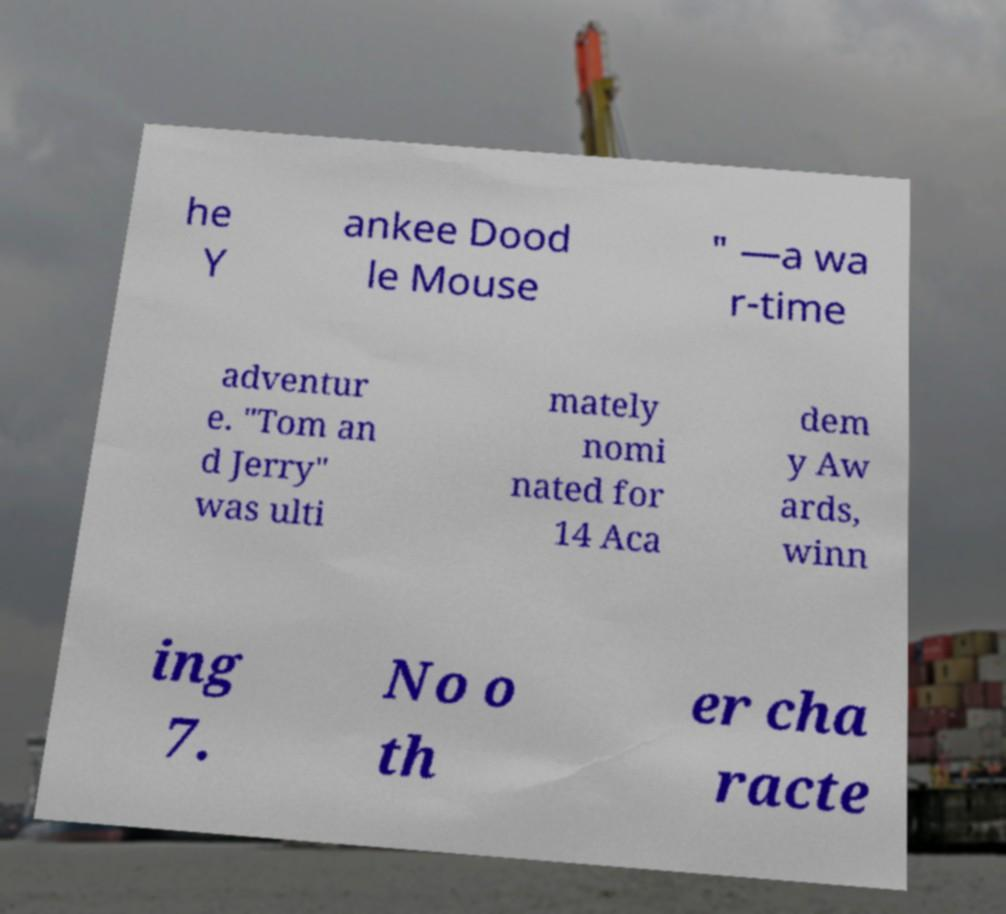I need the written content from this picture converted into text. Can you do that? he Y ankee Dood le Mouse " —a wa r-time adventur e. "Tom an d Jerry" was ulti mately nomi nated for 14 Aca dem y Aw ards, winn ing 7. No o th er cha racte 